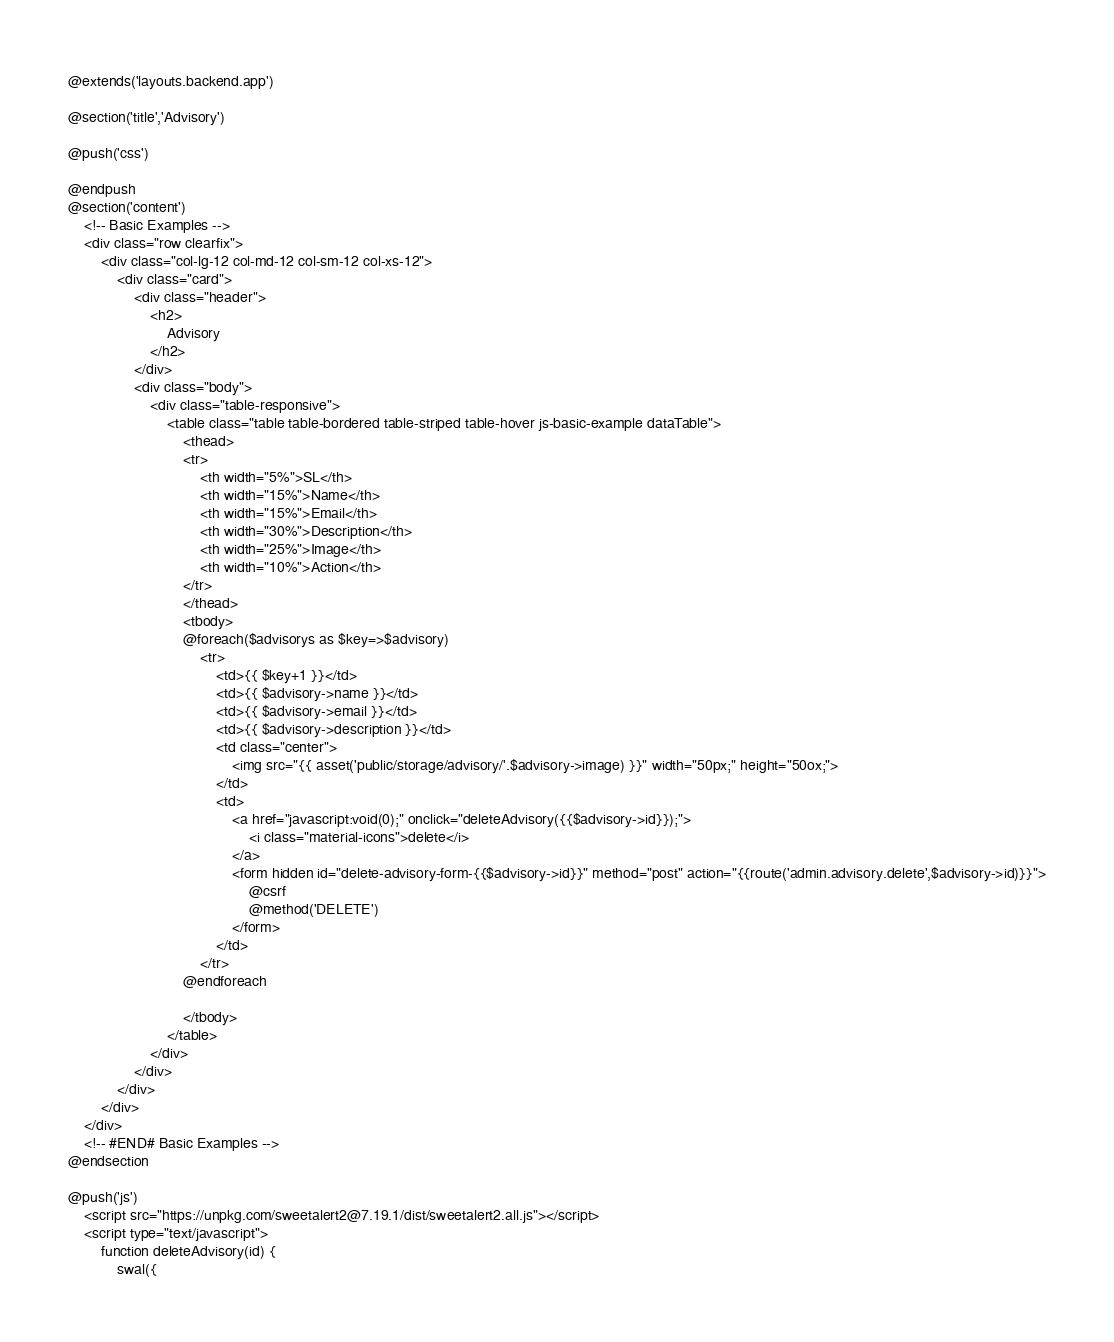<code> <loc_0><loc_0><loc_500><loc_500><_PHP_>@extends('layouts.backend.app')

@section('title','Advisory')

@push('css')

@endpush
@section('content')
    <!-- Basic Examples -->
    <div class="row clearfix">
        <div class="col-lg-12 col-md-12 col-sm-12 col-xs-12">
            <div class="card">
                <div class="header">
                    <h2>
                        Advisory
                    </h2>
                </div>
                <div class="body">
                    <div class="table-responsive">
                        <table class="table table-bordered table-striped table-hover js-basic-example dataTable">
                            <thead>
                            <tr>
                                <th width="5%">SL</th>
                                <th width="15%">Name</th>
                                <th width="15%">Email</th>
                                <th width="30%">Description</th>
                                <th width="25%">Image</th>
                                <th width="10%">Action</th>
                            </tr>
                            </thead>
                            <tbody>
                            @foreach($advisorys as $key=>$advisory)
                                <tr>
                                    <td>{{ $key+1 }}</td>
                                    <td>{{ $advisory->name }}</td>
                                    <td>{{ $advisory->email }}</td>
                                    <td>{{ $advisory->description }}</td>
                                    <td class="center">
                                        <img src="{{ asset('public/storage/advisory/'.$advisory->image) }}" width="50px;" height="50ox;">
                                    </td>
                                    <td>
                                        <a href="javascript:void(0);" onclick="deleteAdvisory({{$advisory->id}});">
                                            <i class="material-icons">delete</i>
                                        </a>
                                        <form hidden id="delete-advisory-form-{{$advisory->id}}" method="post" action="{{route('admin.advisory.delete',$advisory->id)}}">
                                            @csrf
                                            @method('DELETE')
                                        </form>
                                    </td>
                                </tr>
                            @endforeach

                            </tbody>
                        </table>
                    </div>
                </div>
            </div>
        </div>
    </div>
    <!-- #END# Basic Examples -->
@endsection

@push('js')
    <script src="https://unpkg.com/sweetalert2@7.19.1/dist/sweetalert2.all.js"></script>
    <script type="text/javascript">
        function deleteAdvisory(id) {
            swal({</code> 